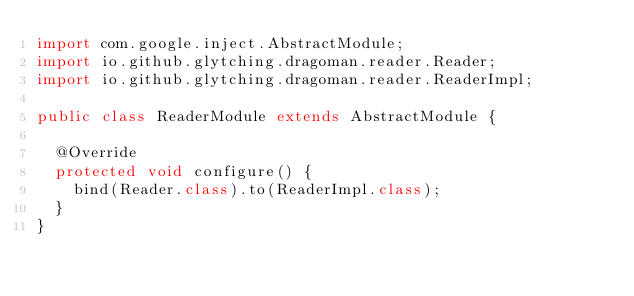<code> <loc_0><loc_0><loc_500><loc_500><_Java_>import com.google.inject.AbstractModule;
import io.github.glytching.dragoman.reader.Reader;
import io.github.glytching.dragoman.reader.ReaderImpl;

public class ReaderModule extends AbstractModule {

  @Override
  protected void configure() {
    bind(Reader.class).to(ReaderImpl.class);
  }
}
</code> 